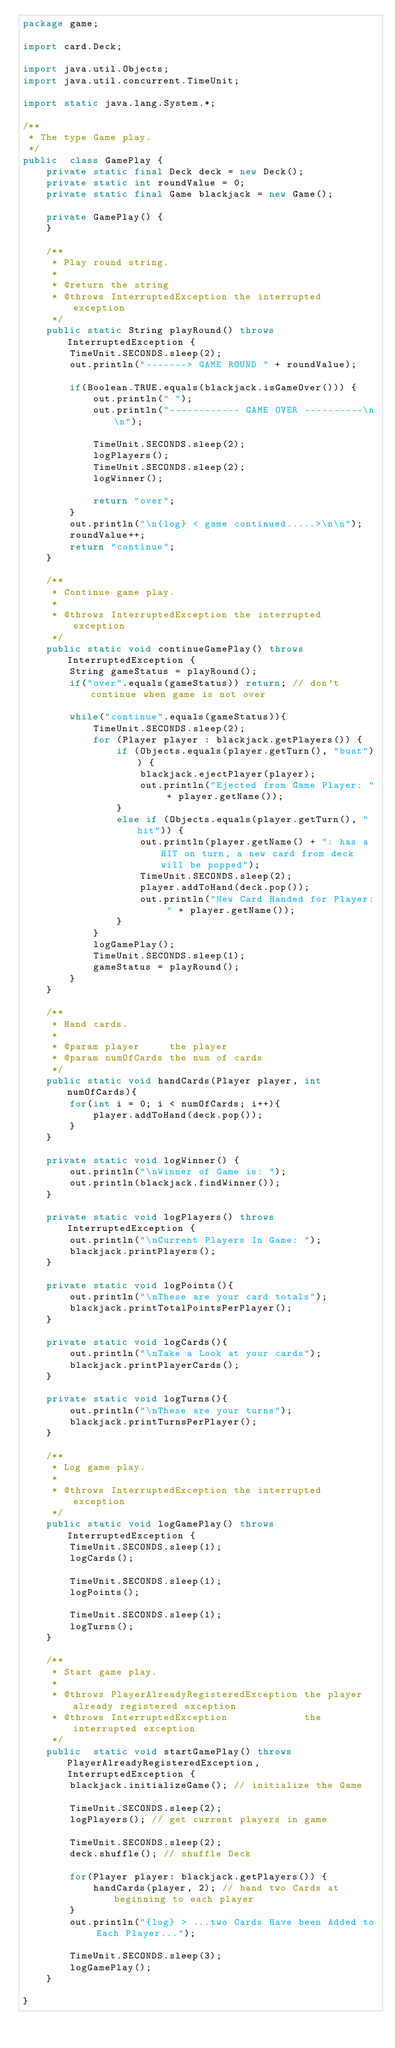Convert code to text. <code><loc_0><loc_0><loc_500><loc_500><_Java_>package game;

import card.Deck;

import java.util.Objects;
import java.util.concurrent.TimeUnit;

import static java.lang.System.*;

/**
 * The type Game play.
 */
public  class GamePlay {
    private static final Deck deck = new Deck();
    private static int roundValue = 0;
    private static final Game blackjack = new Game();

    private GamePlay() {
    }

    /**
     * Play round string.
     *
     * @return the string
     * @throws InterruptedException the interrupted exception
     */
    public static String playRound() throws InterruptedException {
        TimeUnit.SECONDS.sleep(2);
        out.println("-------> GAME ROUND " + roundValue);

        if(Boolean.TRUE.equals(blackjack.isGameOver())) {
            out.println(" ");
            out.println("------------ GAME OVER ----------\n\n");

            TimeUnit.SECONDS.sleep(2);
            logPlayers();
            TimeUnit.SECONDS.sleep(2);
            logWinner();

            return "over";
        }
        out.println("\n{log} < game continued.....>\n\n");
        roundValue++;
        return "continue";
    }

    /**
     * Continue game play.
     *
     * @throws InterruptedException the interrupted exception
     */
    public static void continueGamePlay() throws InterruptedException {
        String gameStatus = playRound();
        if("over".equals(gameStatus)) return; // don't continue when game is not over

        while("continue".equals(gameStatus)){
            TimeUnit.SECONDS.sleep(2);
            for (Player player : blackjack.getPlayers()) {
                if (Objects.equals(player.getTurn(), "bust")) {
                    blackjack.ejectPlayer(player);
                    out.println("Ejected from Game Player: " + player.getName());
                }
                else if (Objects.equals(player.getTurn(), "hit")) {
                    out.println(player.getName() + ": has a HIT on turn, a new card from deck will be popped");
                    TimeUnit.SECONDS.sleep(2);
                    player.addToHand(deck.pop());
                    out.println("New Card Handed for Player: " + player.getName());
                }
            }
            logGamePlay();
            TimeUnit.SECONDS.sleep(1);
            gameStatus = playRound();
        }
    }

    /**
     * Hand cards.
     *
     * @param player     the player
     * @param numOfCards the num of cards
     */
    public static void handCards(Player player, int numOfCards){
        for(int i = 0; i < numOfCards; i++){
            player.addToHand(deck.pop());
        }
    }

    private static void logWinner() {
        out.println("\nWinner of Game is: ");
        out.println(blackjack.findWinner());
    }

    private static void logPlayers() throws InterruptedException {
        out.println("\nCurrent Players In Game: ");
        blackjack.printPlayers();
    }

    private static void logPoints(){
        out.println("\nThese are your card totals");
        blackjack.printTotalPointsPerPlayer();
    }

    private static void logCards(){
        out.println("\nTake a Look at your cards");
        blackjack.printPlayerCards();
    }

    private static void logTurns(){
        out.println("\nThese are your turns");
        blackjack.printTurnsPerPlayer();
    }

    /**
     * Log game play.
     *
     * @throws InterruptedException the interrupted exception
     */
    public static void logGamePlay() throws InterruptedException {
        TimeUnit.SECONDS.sleep(1);
        logCards();

        TimeUnit.SECONDS.sleep(1);
        logPoints();

        TimeUnit.SECONDS.sleep(1);
        logTurns();
    }

    /**
     * Start game play.
     *
     * @throws PlayerAlreadyRegisteredException the player already registered exception
     * @throws InterruptedException             the interrupted exception
     */
    public  static void startGamePlay() throws PlayerAlreadyRegisteredException, InterruptedException {
        blackjack.initializeGame(); // initialize the Game

        TimeUnit.SECONDS.sleep(2);
        logPlayers(); // get current players in game

        TimeUnit.SECONDS.sleep(2);
        deck.shuffle(); // shuffle Deck

        for(Player player: blackjack.getPlayers()) {
            handCards(player, 2); // hand two Cards at beginning to each player
        }
        out.println("{log} > ...two Cards Have been Added to Each Player...");

        TimeUnit.SECONDS.sleep(3);
        logGamePlay();
    }

}
</code> 